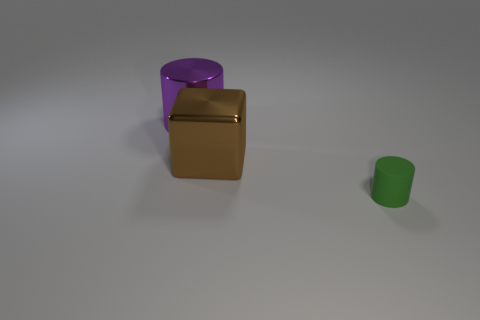Add 3 small green things. How many objects exist? 6 Subtract all cubes. How many objects are left? 2 Add 3 green rubber things. How many green rubber things exist? 4 Subtract 0 brown cylinders. How many objects are left? 3 Subtract all large cyan metal spheres. Subtract all big purple shiny cylinders. How many objects are left? 2 Add 1 big brown metal blocks. How many big brown metal blocks are left? 2 